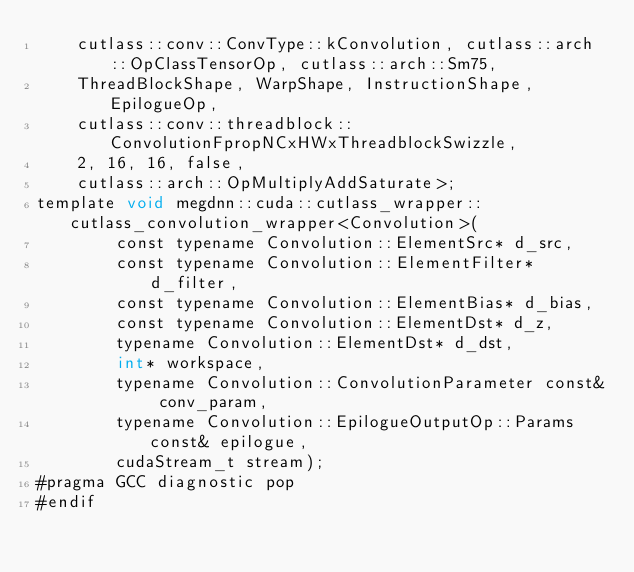<code> <loc_0><loc_0><loc_500><loc_500><_Cuda_>    cutlass::conv::ConvType::kConvolution, cutlass::arch::OpClassTensorOp, cutlass::arch::Sm75, 
    ThreadBlockShape, WarpShape, InstructionShape, EpilogueOp, 
    cutlass::conv::threadblock::ConvolutionFpropNCxHWxThreadblockSwizzle, 
    2, 16, 16, false, 
    cutlass::arch::OpMultiplyAddSaturate>;
template void megdnn::cuda::cutlass_wrapper::cutlass_convolution_wrapper<Convolution>(
        const typename Convolution::ElementSrc* d_src, 
        const typename Convolution::ElementFilter* d_filter, 
        const typename Convolution::ElementBias* d_bias, 
        const typename Convolution::ElementDst* d_z, 
        typename Convolution::ElementDst* d_dst, 
        int* workspace, 
        typename Convolution::ConvolutionParameter const& conv_param, 
        typename Convolution::EpilogueOutputOp::Params const& epilogue, 
        cudaStream_t stream);
#pragma GCC diagnostic pop
#endif
</code> 